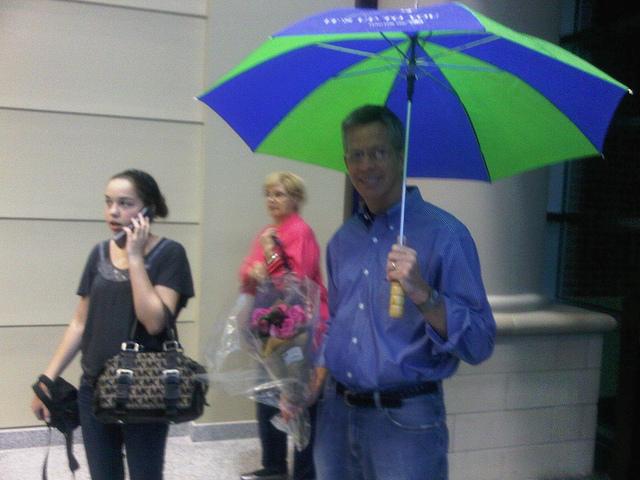What is the man holding in his left hand?
Concise answer only. Umbrella. How many people in this picture are carrying bags?
Give a very brief answer. 2. Does she dress like this regularly?
Be succinct. Yes. Which person is smoking?
Quick response, please. None. Why are some holding umbrellas?
Concise answer only. Rain. What is the woman holding?
Concise answer only. Phone. What type of umbrella is she holding?
Keep it brief. Rain. What color is the woman's shirt?
Quick response, please. Black. Are the people kissing?
Answer briefly. No. Who has the umbrella?
Answer briefly. Man. Is it raining?
Short answer required. No. What color is the umbrella?
Short answer required. Blue and green. 